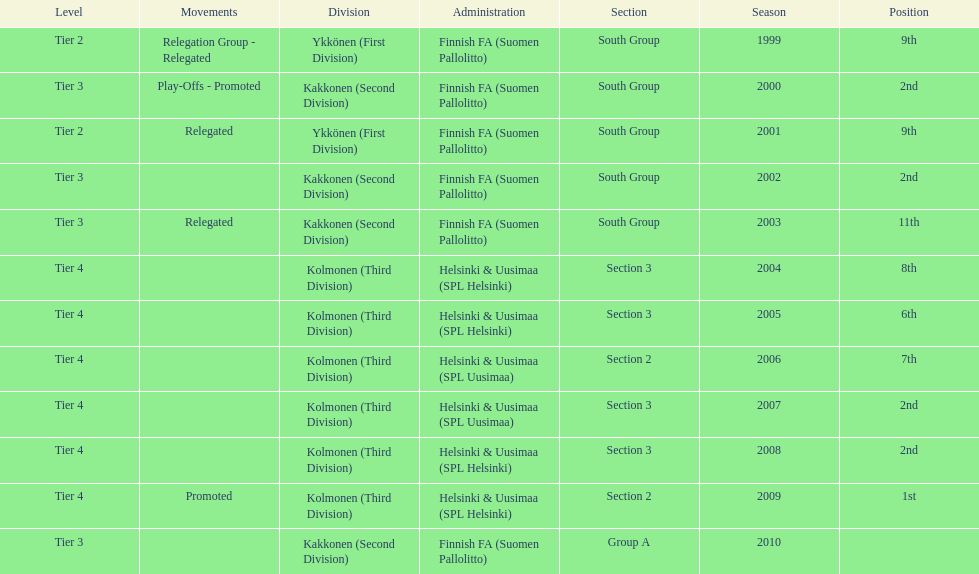How many consecutive times did they play in tier 4? 6. 